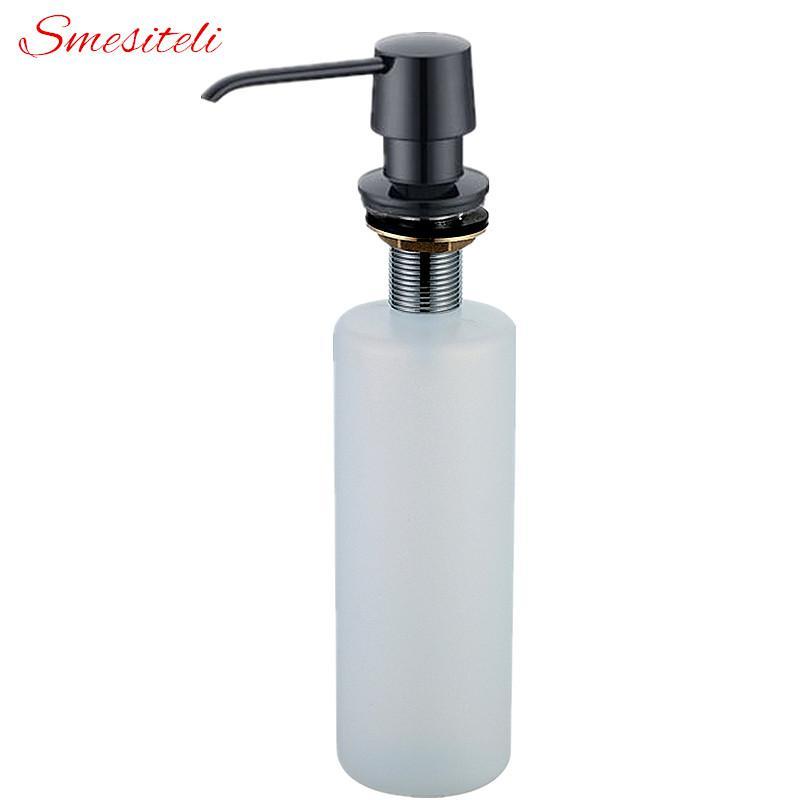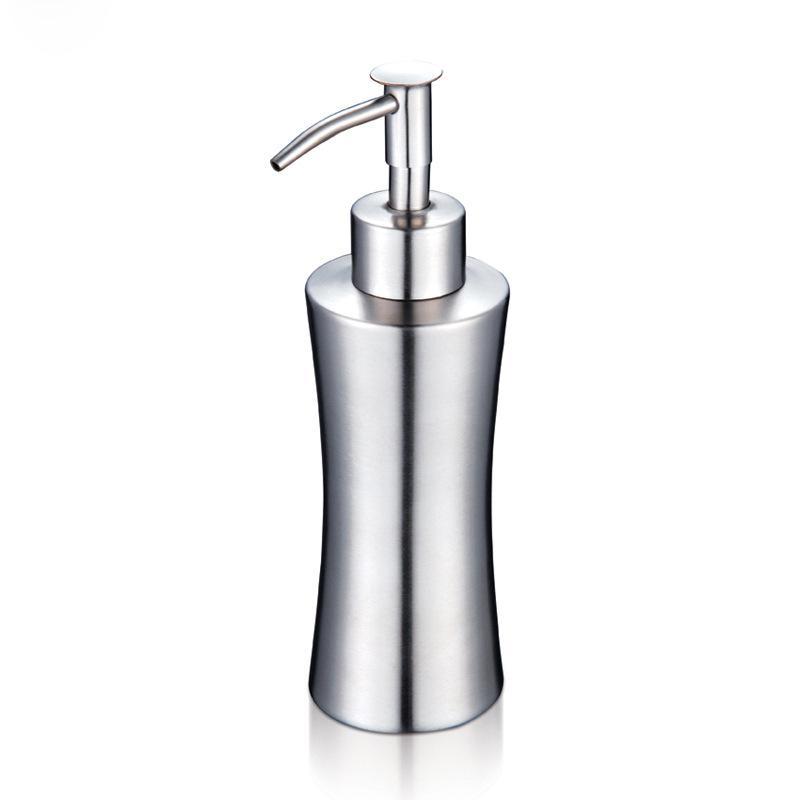The first image is the image on the left, the second image is the image on the right. Given the left and right images, does the statement "The pump spigots are all facing to the left." hold true? Answer yes or no. Yes. 